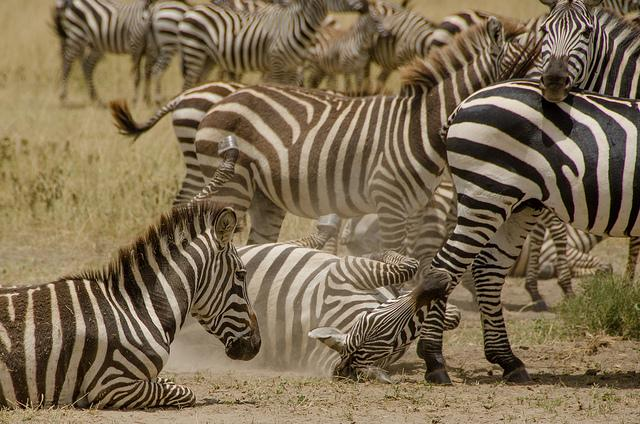How would these animals be classified?

Choices:
A) pescatarian
B) omnivores
C) carnivores
D) herbivores herbivores 